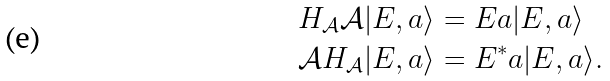Convert formula to latex. <formula><loc_0><loc_0><loc_500><loc_500>H _ { \mathcal { A } } \mathcal { A } | E , a \rangle & = E a | E , a \rangle \\ \mathcal { A } H _ { \mathcal { A } } | E , a \rangle & = E ^ { * } a | E , a \rangle .</formula> 